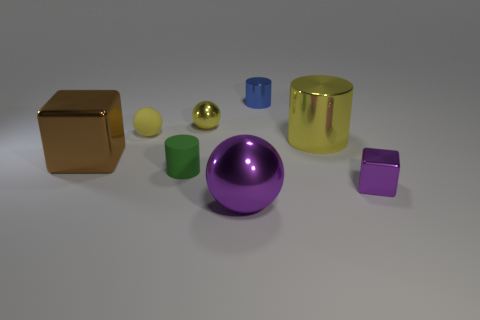How many tiny things are both on the right side of the green rubber cylinder and behind the green cylinder?
Give a very brief answer. 2. There is a large metallic object that is the same color as the small metallic cube; what is its shape?
Your response must be concise. Sphere. Is the material of the tiny purple object the same as the large yellow cylinder?
Give a very brief answer. Yes. The matte thing that is in front of the metallic thing on the left side of the small green cylinder left of the purple cube is what shape?
Make the answer very short. Cylinder. Is the number of big shiny cylinders to the left of the tiny yellow metal object less than the number of small things that are in front of the yellow matte ball?
Your response must be concise. Yes. There is a yellow metal thing that is on the right side of the tiny yellow sphere that is right of the rubber cylinder; what is its shape?
Provide a succinct answer. Cylinder. Is there any other thing that has the same color as the large cube?
Make the answer very short. No. Do the matte cylinder and the large cylinder have the same color?
Make the answer very short. No. How many green things are tiny things or large shiny cubes?
Make the answer very short. 1. Is the number of balls behind the brown thing less than the number of big metallic cylinders?
Give a very brief answer. No. 